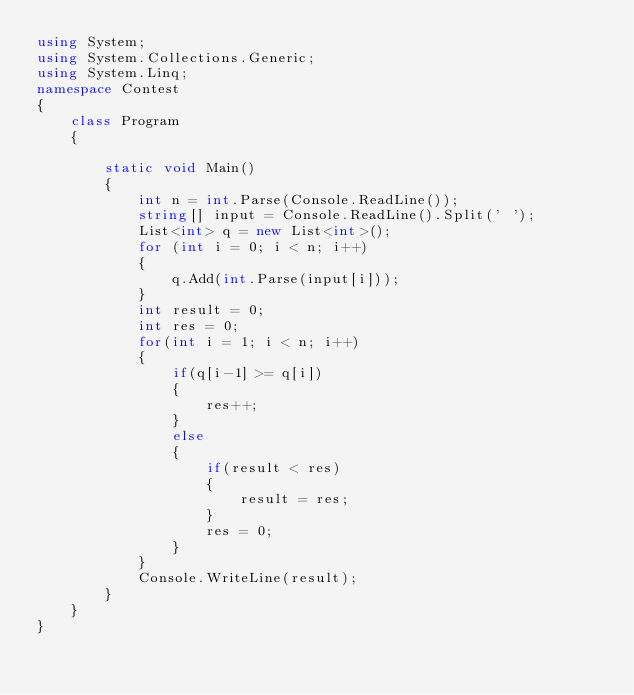<code> <loc_0><loc_0><loc_500><loc_500><_C#_>using System;
using System.Collections.Generic;
using System.Linq;
namespace Contest
{
    class Program
    {

        static void Main()
        {
            int n = int.Parse(Console.ReadLine());
            string[] input = Console.ReadLine().Split(' ');
            List<int> q = new List<int>();
            for (int i = 0; i < n; i++)
            {
                q.Add(int.Parse(input[i]));
            }
            int result = 0;
            int res = 0;
            for(int i = 1; i < n; i++)
            {
                if(q[i-1] >= q[i])
                {
                    res++;
                }
                else
                {
                    if(result < res)
                    {
                        result = res;
                    }
                    res = 0;
                }
            }
            Console.WriteLine(result);
        }
    }
}
</code> 